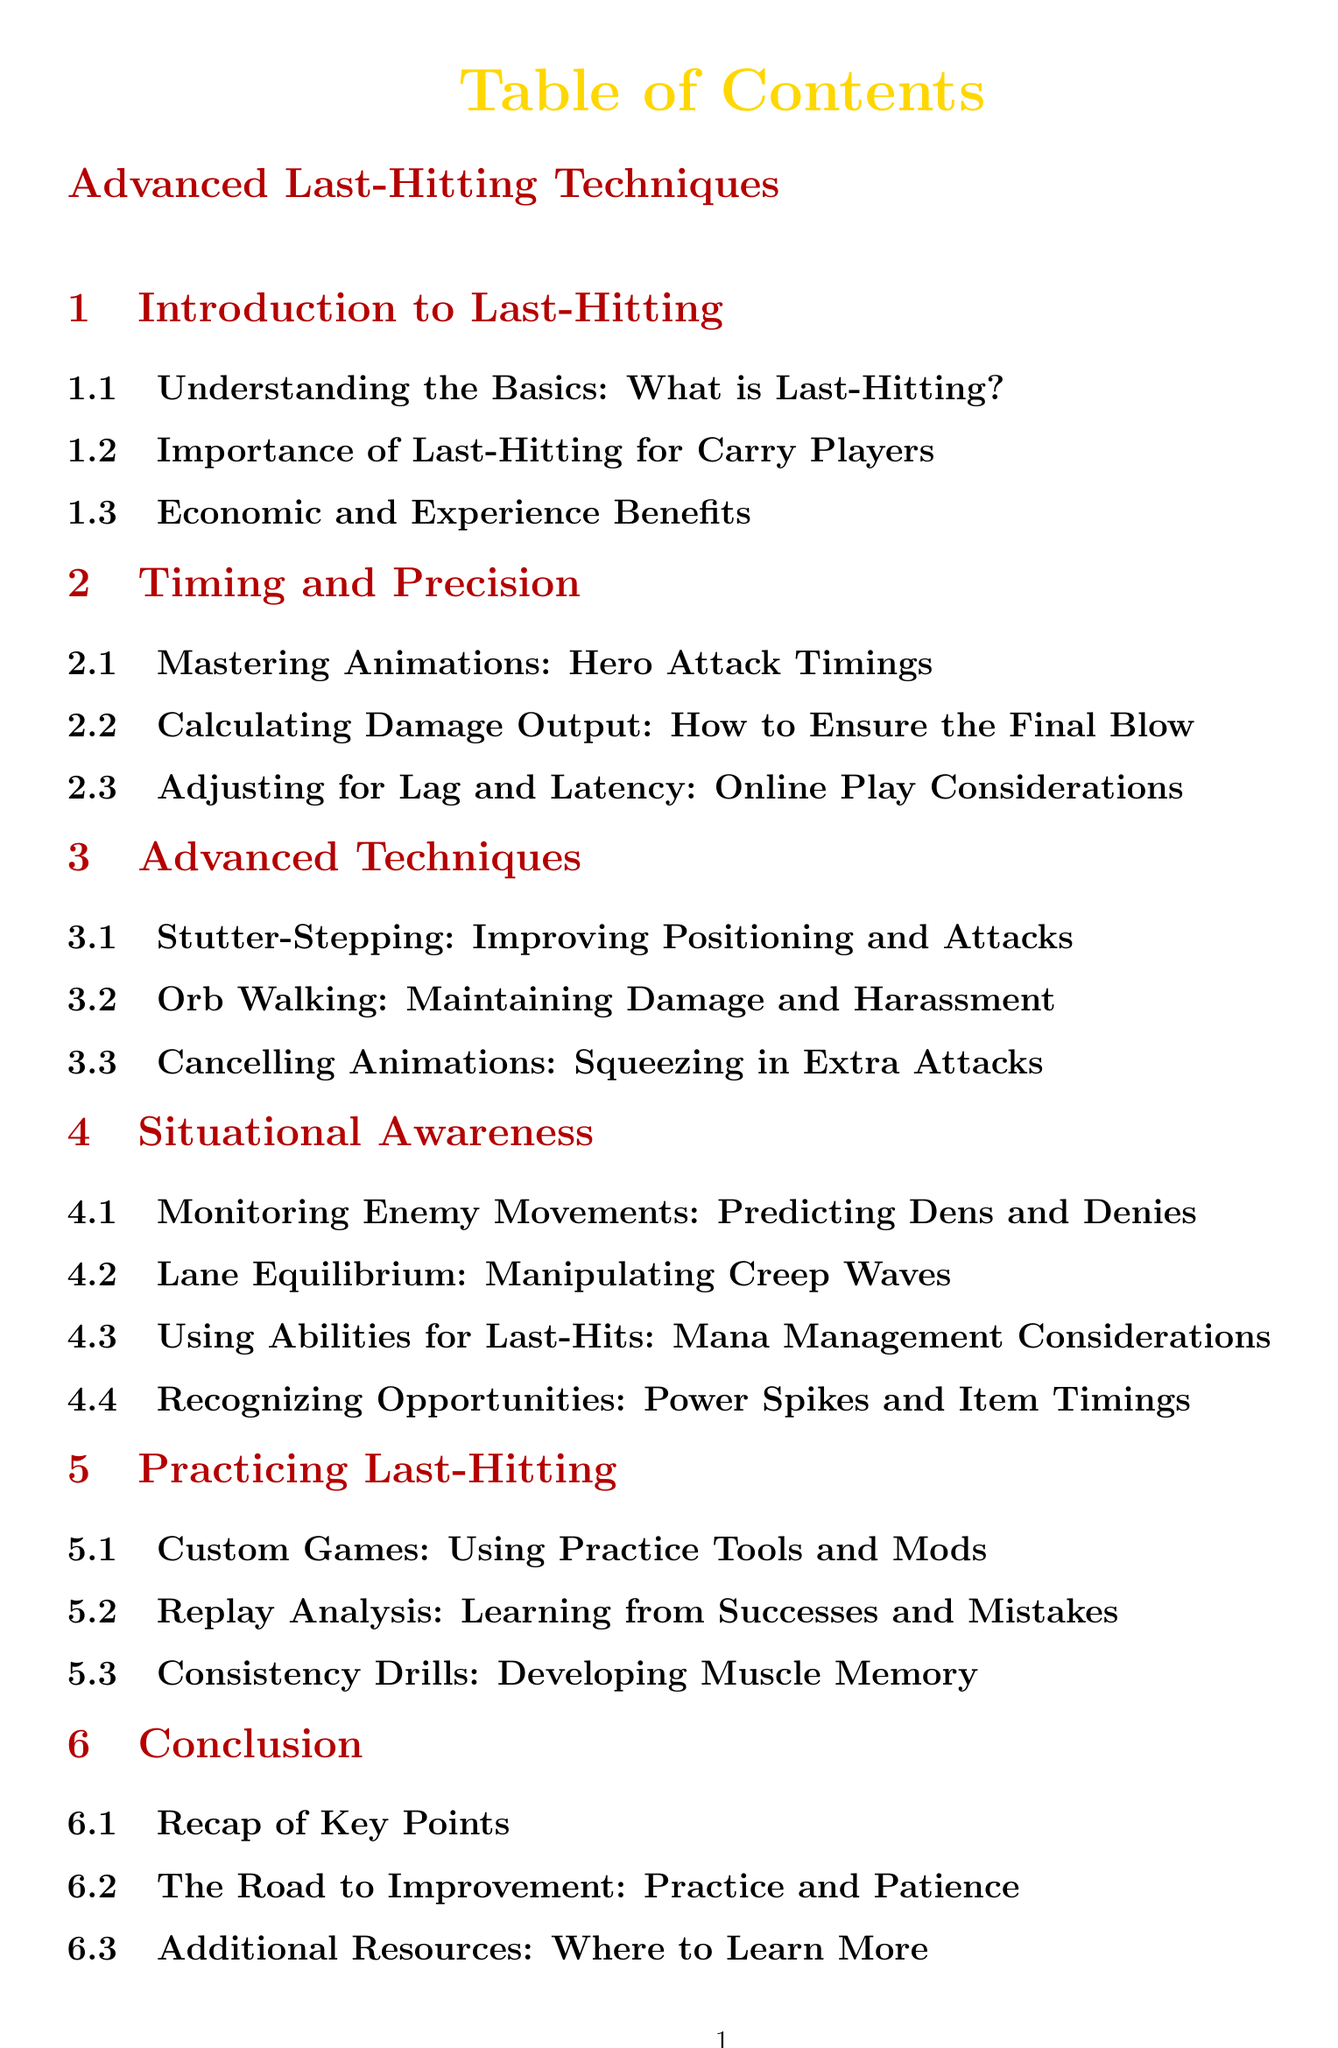what is the first section of the document? The first section in the Table of Contents is "Introduction to Last-Hitting."
Answer: Introduction to Last-Hitting how many subsections are in the "Advanced Techniques" section? The "Advanced Techniques" section contains three subsections.
Answer: 3 what color is used for the title of the document? The title color specified in the document is carry gold.
Answer: carry gold what type of games are suggested for practicing last-hitting? The document suggests using custom games for practicing last-hitting.
Answer: Custom Games which subsection discusses the use of abilities for last-hits? The subsection that discusses the use of abilities for last-hits is "Using Abilities for Last-Hits."
Answer: Using Abilities for Last-Hits what is the main focus of the "Situational Awareness" section? The focus of the "Situational Awareness" section is on understanding and reacting to game dynamics.
Answer: Understanding and reacting to game dynamics how many total sections are there in the document? The document contains six main sections.
Answer: 6 what is the last section of the document? The last section of the document is "Conclusion."
Answer: Conclusion 